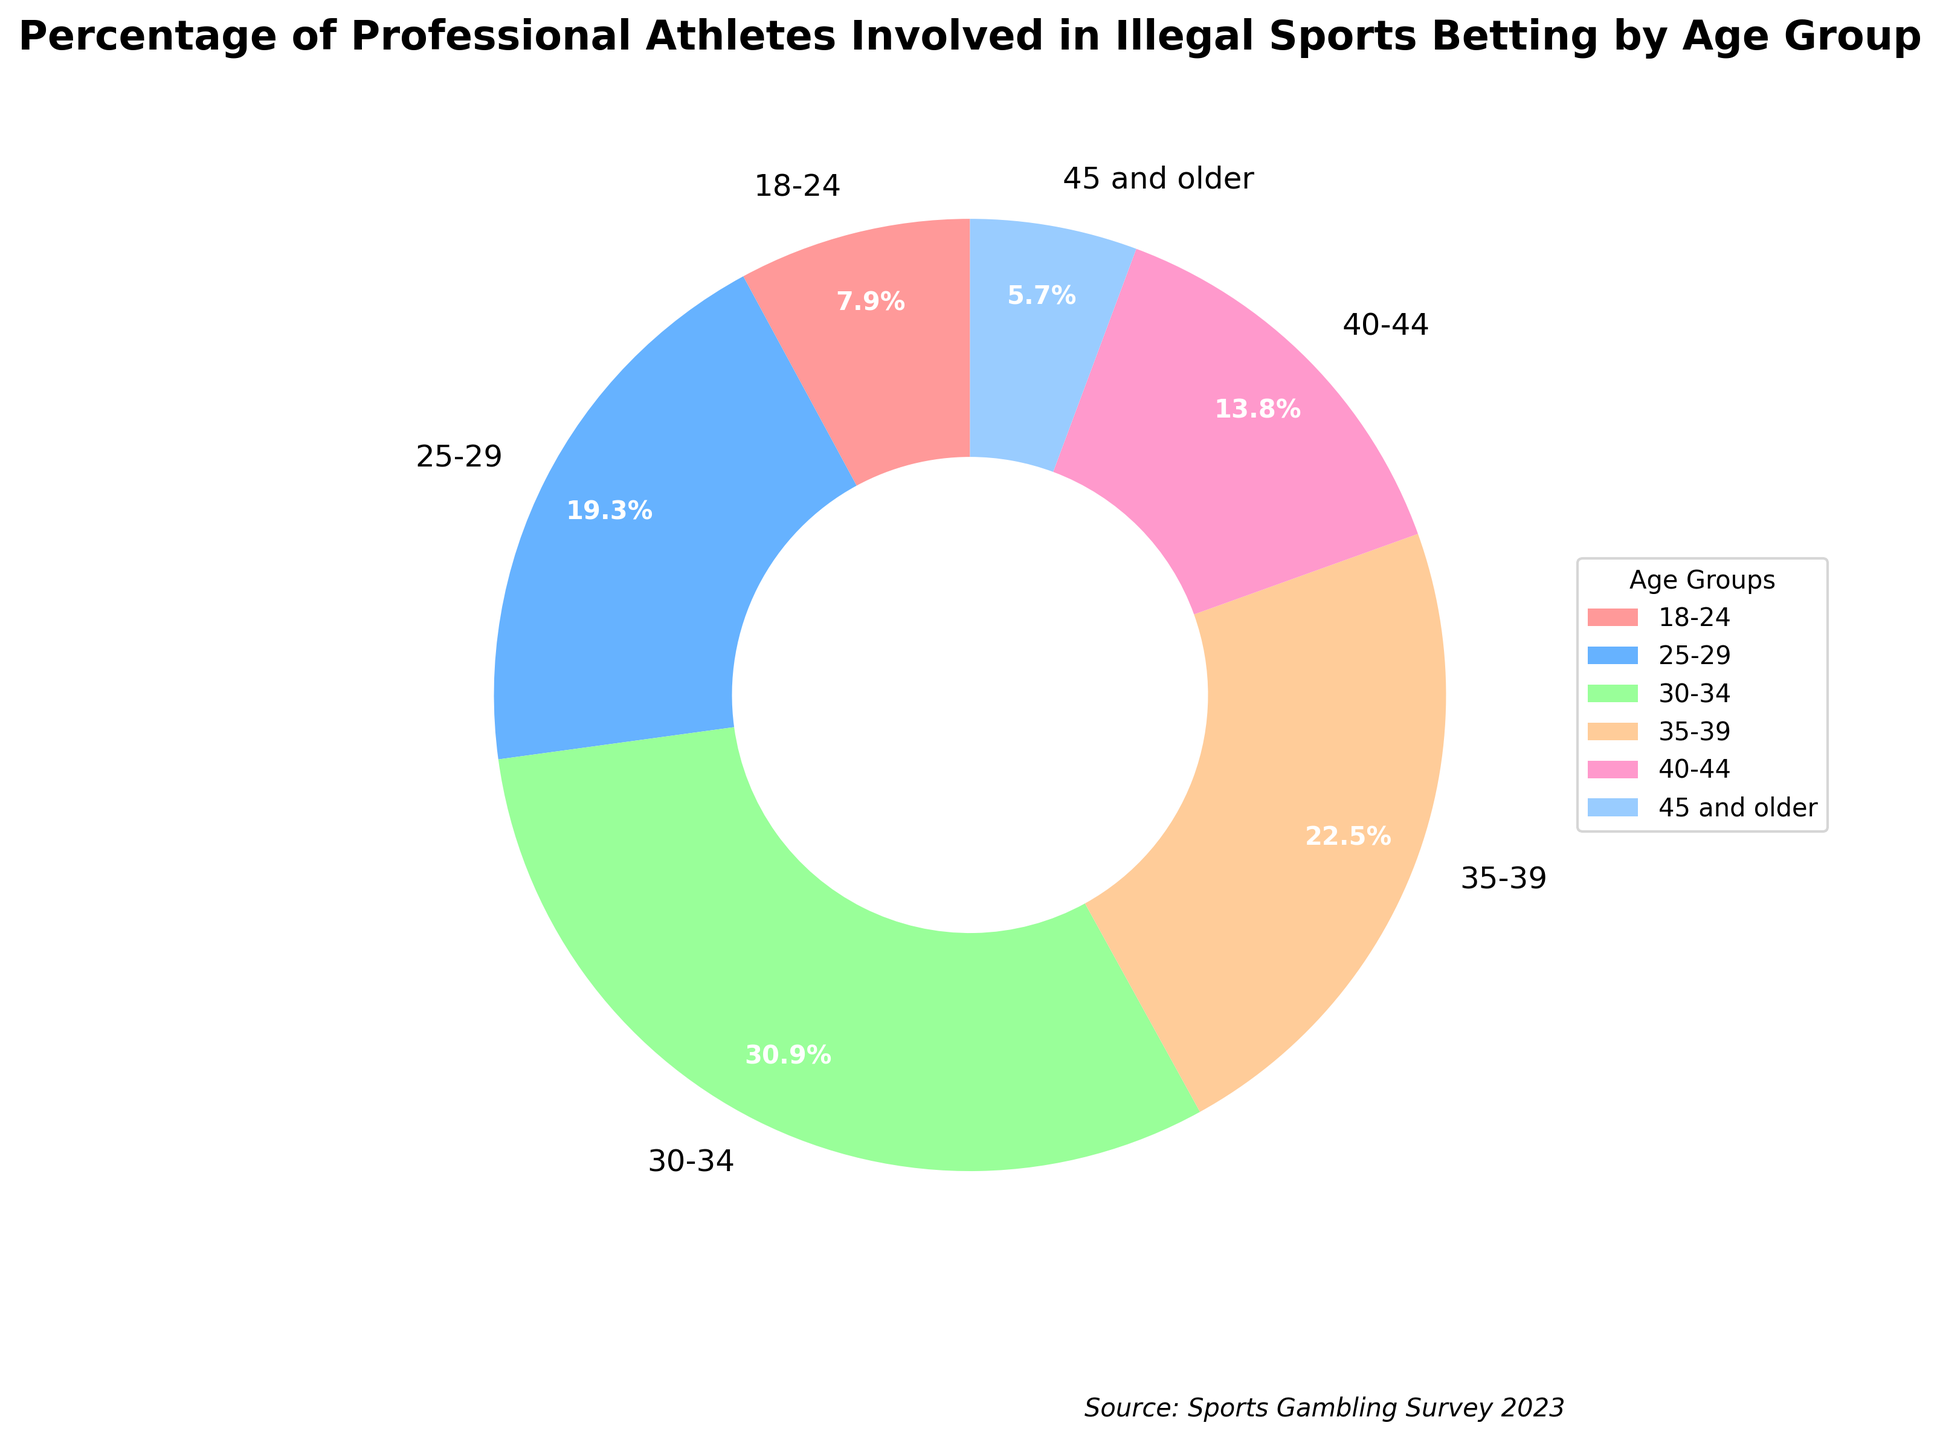What's the percentage of professional athletes aged 25-29 involved in illegal sports betting? Refer to the age group label "25-29" in the pie chart and identify the associated percentage.
Answer: 7.8% Which age group has the highest percentage of professional athletes involved in illegal sports betting? Look at the pie chart and identify the age group with the largest wedge or the highest percentage label.
Answer: 30-34 What is the combined percentage of professional athletes aged 18-24 and 45 and older involved in illegal sports betting? Sum the percentages of the "18-24" and "45 and older" age groups: 3.2% + 2.3%.
Answer: 5.5% Which age group has a higher involvement in illegal sports betting, 35-39 or 40-44? Compare the percentages of the age groups "35-39" and "40-44" from the pie chart: 9.1% vs. 5.6%.
Answer: 35-39 Is the percentage of professional athletes aged 30-34 involved in illegal sports betting greater or smaller than the combined percentage of athletes aged 18-24 and 45 and older? Compare the percentage of the "30-34" age group (12.5%) to the combined percentage of the "18-24" and "45 and older" age groups (5.5%).
Answer: Greater Which color represents the age group with the second lowest percentage of involvement in illegal sports betting, and what is that percentage? Identify the second smallest wedge, note its associated age group and color, and verify the percentage: "45 and older" (color and percentage given).
Answer: Color associated with "45 and older", 2.3% How much greater is the percentage of athletes aged 35-39 involved in illegal sports betting compared to those aged 40-44? Subtract the percentage of "40-44" from the percentage of "35-39": 9.1% - 5.6%.
Answer: 3.5% What percentage of professional athletes aged 30-34 and 35-39 combined are involved in illegal sports betting? Sum the percentages for "30-34" and "35-39": 12.5% + 9.1%.
Answer: 21.6% Which age group has the smallest wedge in the pie chart and what is the associated percentage? Identify the smallest wedge visually in terms of size and refer to its percentage.
Answer: 45 and older, 2.3% 